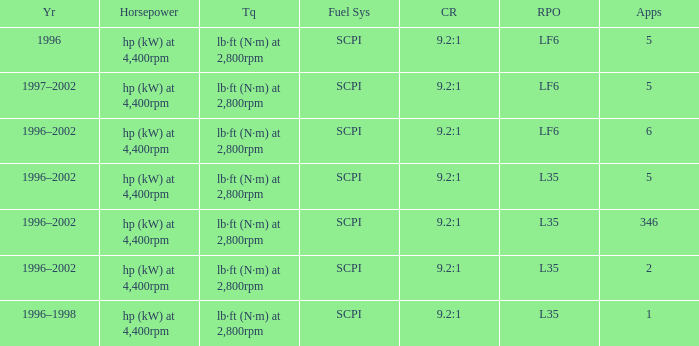What are the torque characteristics of the model with 346 applications? Lb·ft (n·m) at 2,800rpm. 